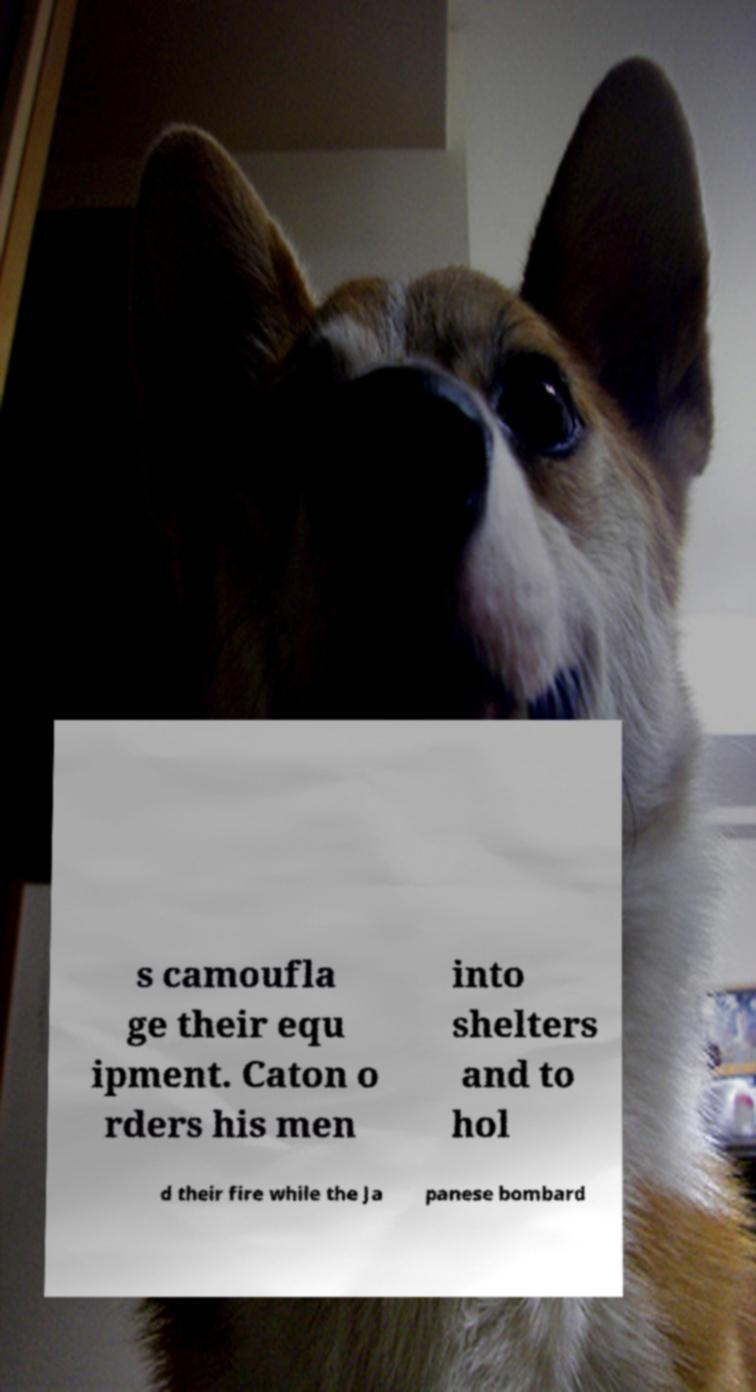Could you assist in decoding the text presented in this image and type it out clearly? s camoufla ge their equ ipment. Caton o rders his men into shelters and to hol d their fire while the Ja panese bombard 